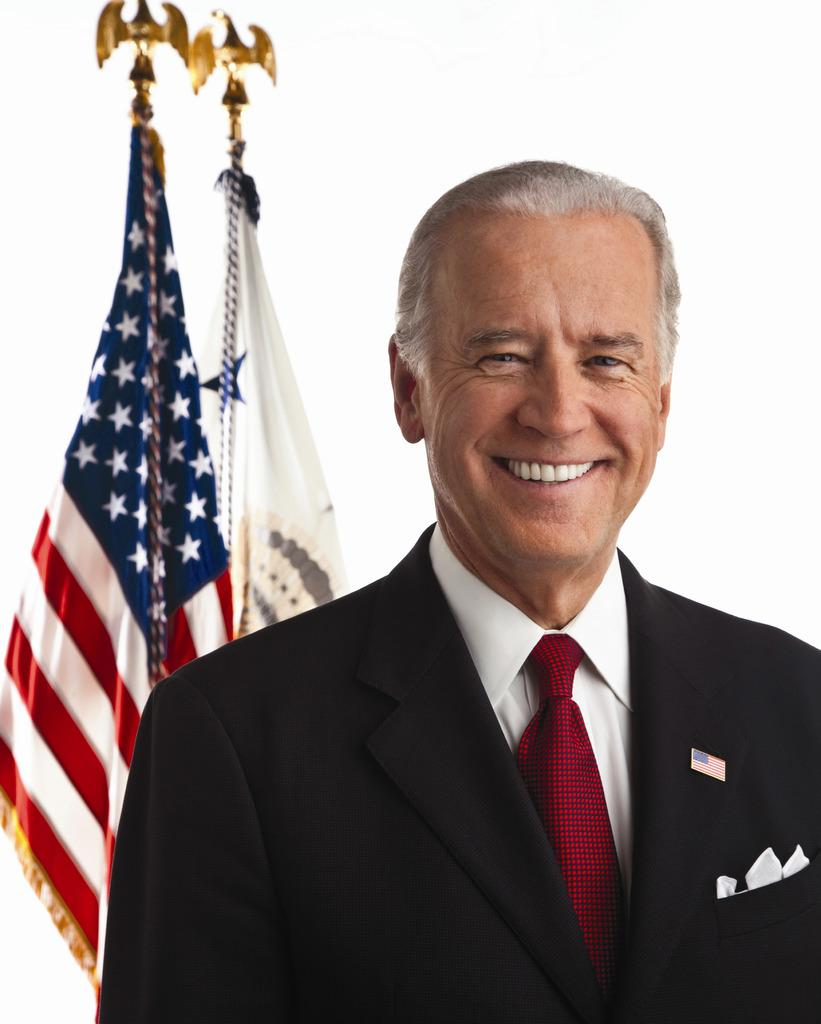What is present in the image? There is a person in the image. How is the person's expression? The person is smiling. What can be seen in the background of the image? There are flags in the background of the image. What type of tools is the carpenter using in the image? There is no carpenter present in the image, nor are there any tools visible. How many pigs can be seen playing with the ball in the image? There are no pigs or balls present in the image. 